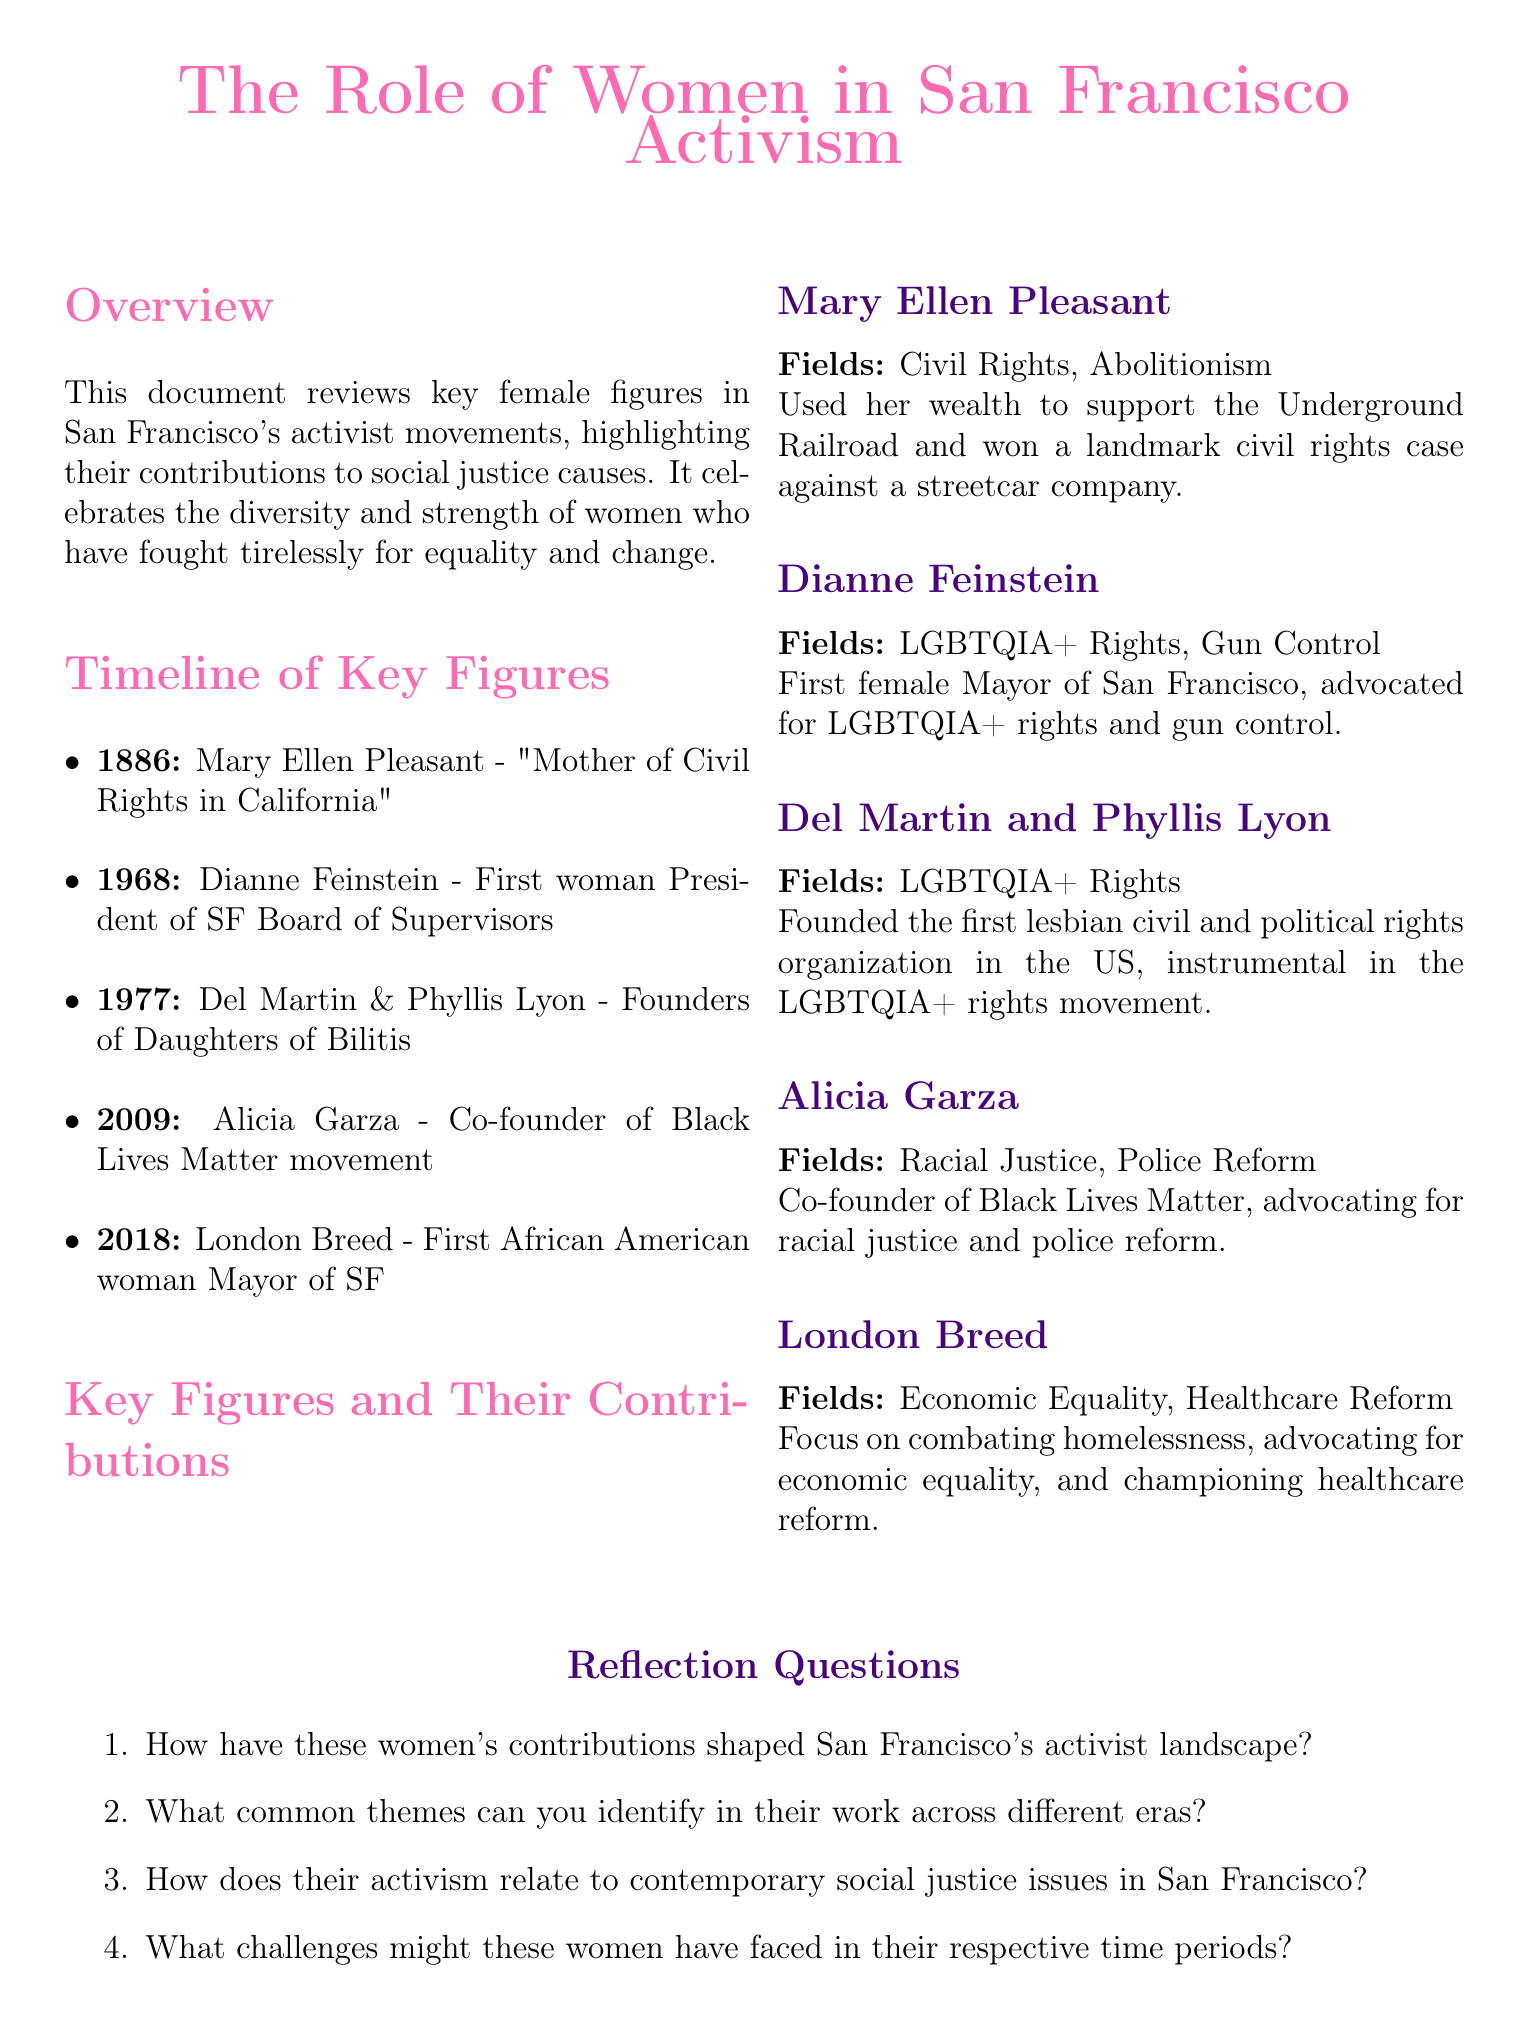What year did Mary Ellen Pleasant win her landmark civil rights case? The document states that Mary Ellen Pleasant was active in 1886, winning a landmark civil rights case in that year.
Answer: 1886 Who co-founded the Black Lives Matter movement? Alicia Garza is mentioned as the co-founder of the Black Lives Matter movement in 2009.
Answer: Alicia Garza What was Dianne Feinstein's notable position in 1968? The document highlights that she was the first woman President of the SF Board of Supervisors in that year.
Answer: First woman President of SF Board of Supervisors Which two women founded the Daughters of Bilitis? Del Martin and Phyllis Lyon are specified as the founders of the Daughters of Bilitis.
Answer: Del Martin & Phyllis Lyon What common field does London Breed focus on? The document mentions her focus on economic equality and healthcare reform, which are common fields addressed in her activism.
Answer: Economic equality What is a significant theme reflected in the contributions of these women? A common theme across their contributions is the fight for civil rights and equality.
Answer: Civil rights and equality What significant event occurred in 2018 regarding female leadership in San Francisco? The document notes that London Breed became the first African American woman Mayor of San Francisco in 2018.
Answer: First African American woman Mayor of SF What role did Mary Ellen Pleasant play in the Underground Railroad? The document states that she used her wealth to support the Underground Railroad.
Answer: Supported the Underground Railroad What major social issue is connected to Alicia Garza's activism? The document connects her work primarily to racial justice and police reform.
Answer: Racial justice 